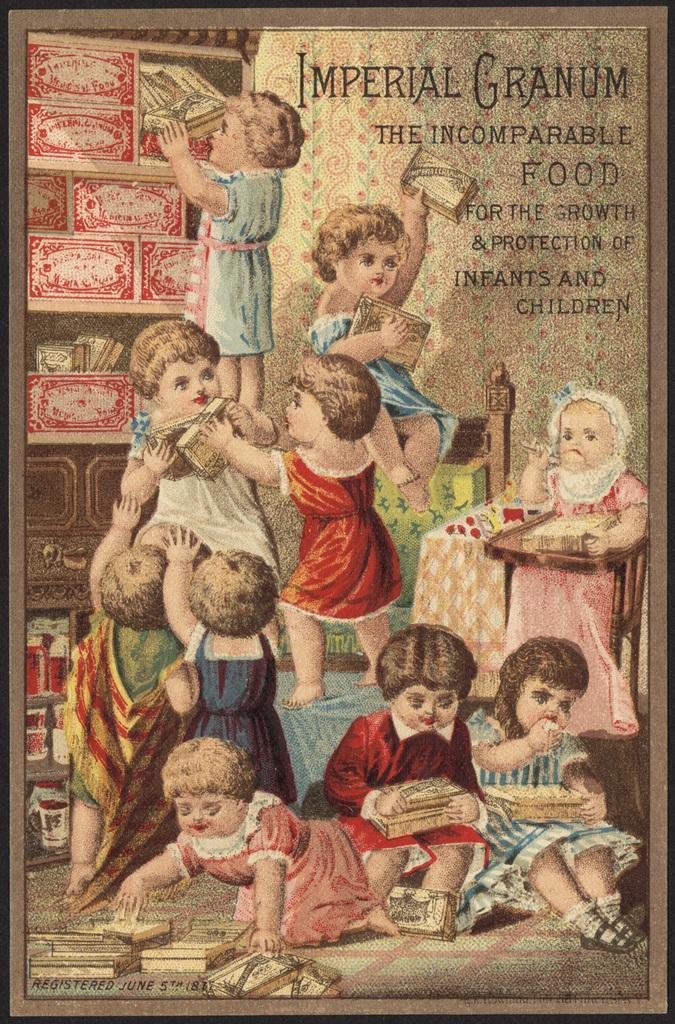Describe this image in one or two sentences. In this image there is a poster with some images of children's and objects with some text on it. 